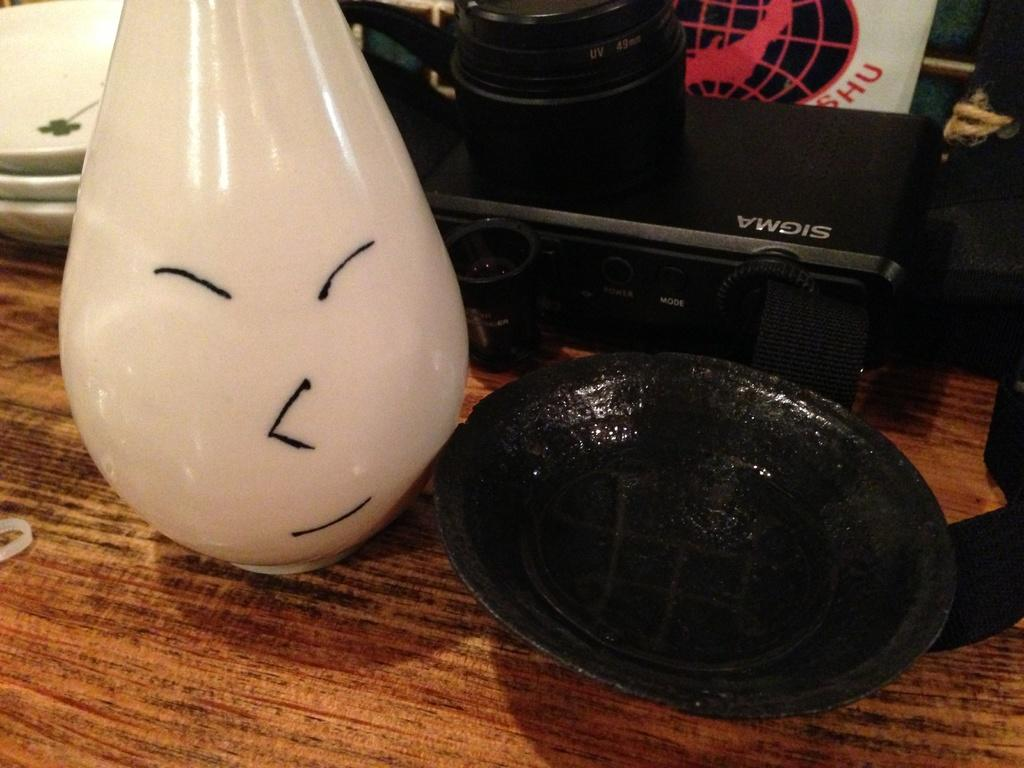Can you describe the objects present in the image? Unfortunately, the provided facts do not offer a detailed description of the objects in the image. Is there a loaf of bread with a finger wound on it in the image? There is no mention of a loaf of bread, finger, or wound in the provided facts, so it cannot be determined if such an object is present in the image. 